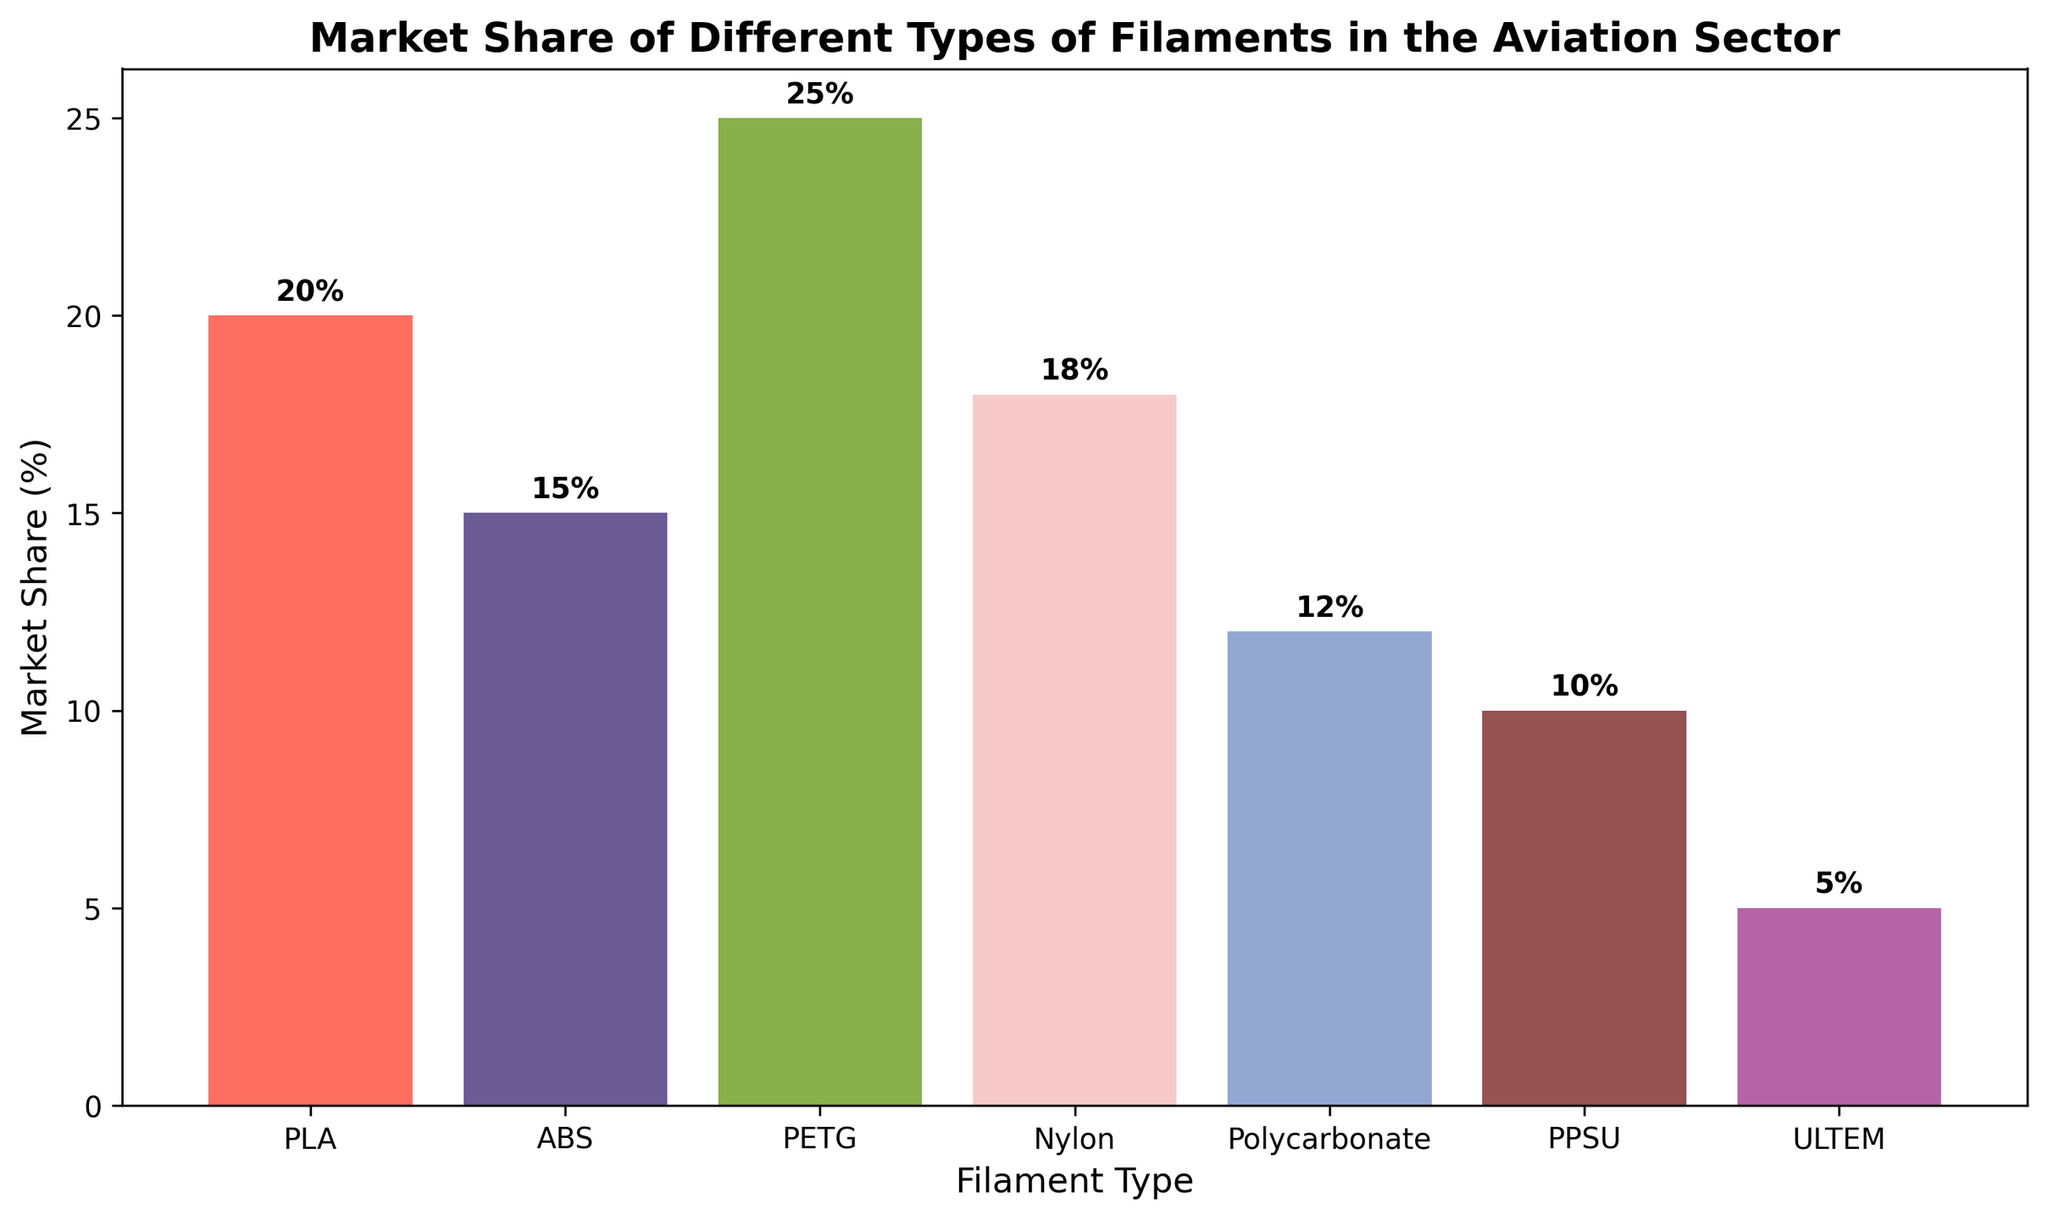Which filament type holds the largest market share? The figure shows that PETG has the highest bar amongst all filament types, signifying its highest market share.
Answer: PETG Which filament type has the smallest market share? The ULTRAM bar is shortest, indicating it has the smallest market share.
Answer: ULTRAM What's the combined market share of Nylon and ABS filaments? The market share of Nylon is 18% and ABS is 15%, so combined it is 18 + 15 = 33%.
Answer: 33% Which filament type has a market share greater than Polycarbonate but less than PLA? Polycarbonate has a 12% market share, and PLA has a 20% market share. Nylon, which has an 18% market share, fits this condition.
Answer: Nylon What’s the difference in market share between the filament with the highest share and the one with the lowest share? PETG has the highest market share at 25%, and ULTRAM has the lowest at 5%. The difference is 25 - 5 = 20%.
Answer: 20% What is the average market share of the six most popular filament types? The market shares of the six most popular filaments: PLA (20%), ABS (15%), PETG (25%), Nylon (18%), Polycarbonate (12%), and PPSU (10%). The average is (20+15+25+18+12+10)/6 = 16.67%.
Answer: 16.67% How much higher is PETG’s market share compared to ABS’s? PETG has a market share of 25%, while ABS has 15%. The difference is 25 - 15 = 10%.
Answer: 10% Out of PLA and Polycarbonate, which one has a higher market share by percentage points, and by how much? PLA has a market share of 20%, while Polycarbonate has 12%. PLA has a higher market share by 20 - 12 = 8 percentage points.
Answer: PLA, 8% What is the sum of the market shares of all filament types except PPSU and ULTRAM? The market shares to sum are: PLA (20%), ABS (15%), PETG (25%), Nylon (18%), Polycarbonate (12%). Sum = 20 + 15 + 25 + 18 + 12 = 90%.
Answer: 90% Looking at the color of the bars, which filament types are represented by shades of blue? The bars for Polycarbonate and PPSU are in shades of blue.
Answer: Polycarbonate and PPSU 